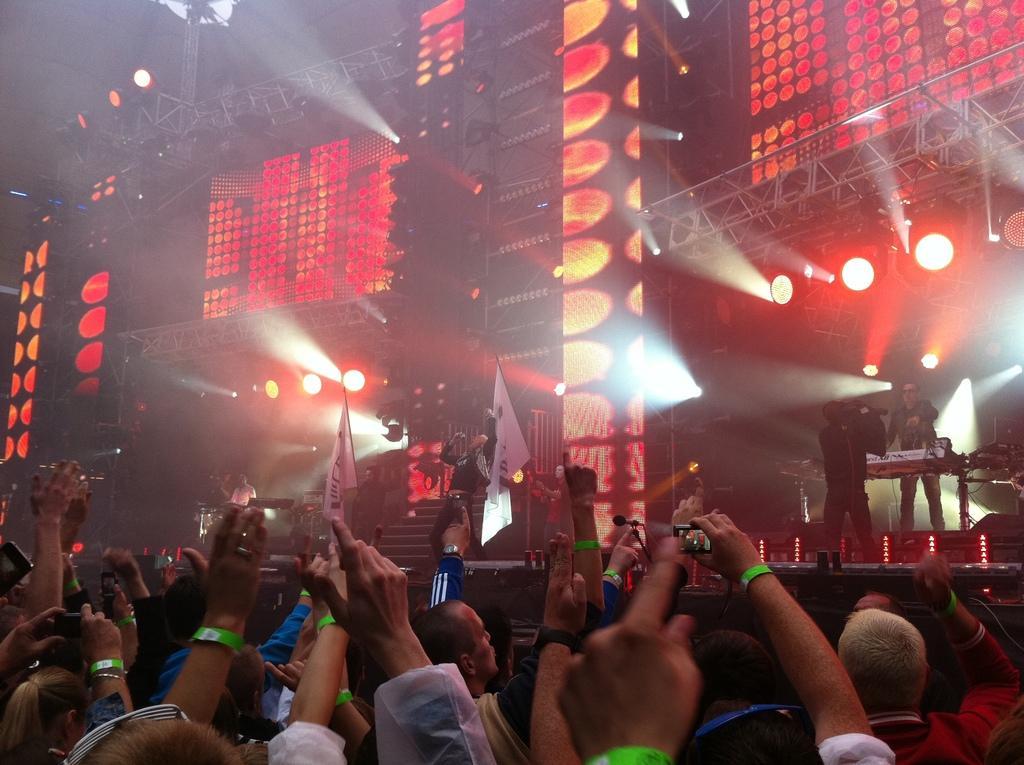Can you describe this image briefly? In the picture we can see a musical event with some people are playing musical instruments and near to them, we can see many people are raising their hands and holding flags and capturing the pictures in the mobile phone and in the background we can see many lights to the stands and focus lights. 